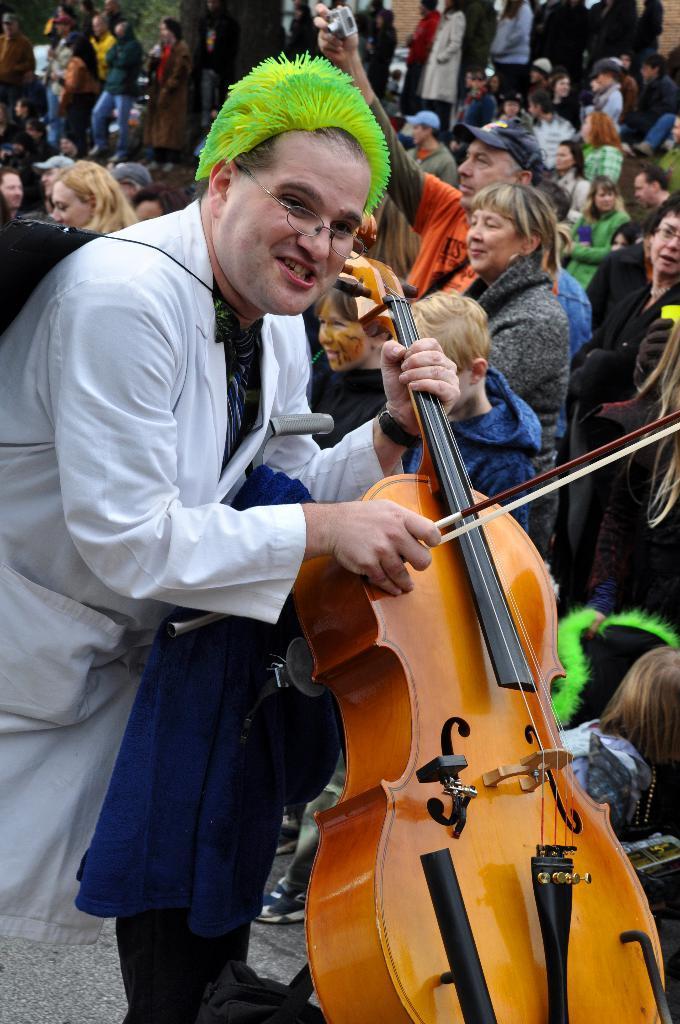In one or two sentences, can you explain what this image depicts? This is a picture taken in the outdoor, there is a man in white shirt holding a violin and background of this there are group of people standing on the floor. 